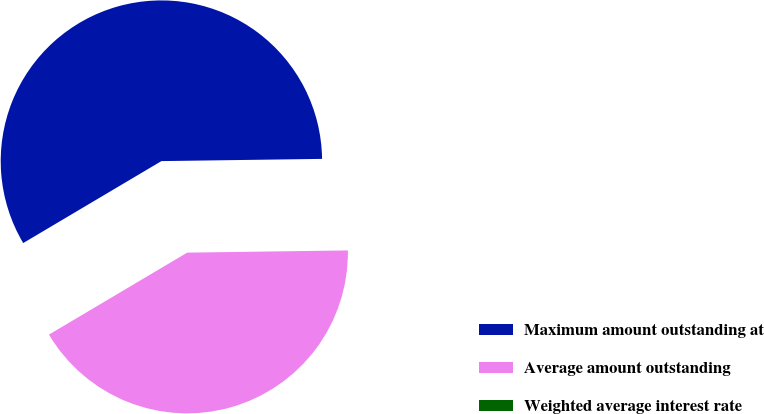Convert chart to OTSL. <chart><loc_0><loc_0><loc_500><loc_500><pie_chart><fcel>Maximum amount outstanding at<fcel>Average amount outstanding<fcel>Weighted average interest rate<nl><fcel>58.3%<fcel>41.7%<fcel>0.0%<nl></chart> 